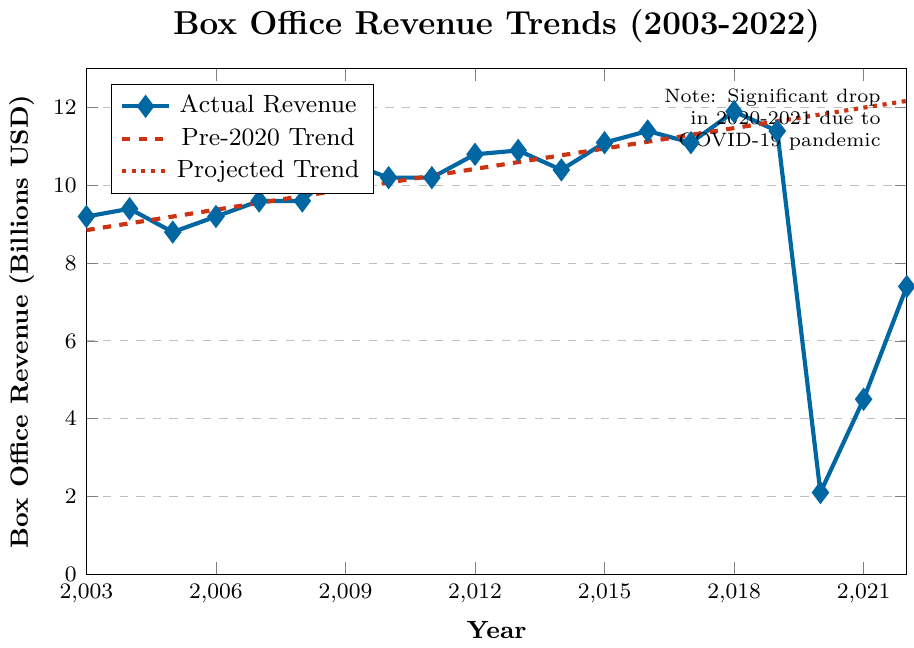How did the box office revenue change from 2019 to 2020? The box office revenue dropped dramatically from 11.4 billion USD in 2019 to 2.1 billion USD in 2020. This is a difference of 11.4 - 2.1 = 9.3 billion USD.
Answer: It decreased by 9.3 billion USD Which year had the highest box office revenue between 2003 and 2022? The highest box office revenue occurred in 2018, with a revenue of 11.9 billion USD, according to the graph.
Answer: 2018 What is the general trend of box office revenues from 2003 to 2019? The general trend is an increasing one. From 2003 to 2019, the box office revenue shows a gradual increase from 9.2 billion USD in 2003 to 11.4 billion USD in 2019.
Answer: Increasing trend What is the difference in box office revenue between the highest and lowest years on the graph? The highest box office revenue is 11.9 billion USD in 2018, and the lowest is 2.1 billion USD in 2020. The difference is 11.9 - 2.1 = 9.8 billion USD.
Answer: 9.8 billion USD How did the box office revenue change from 2021 to 2022, and by how much? The box office revenue increased from 4.5 billion USD in 2021 to 7.4 billion USD in 2022. The change is an increase of 7.4 - 4.5 = 2.9 billion USD.
Answer: Increased by 2.9 billion USD Which years show the revenue staying the same, and what was the revenue? The years 2007 and 2008 both show the same box office revenue of 9.6 billion USD.
Answer: 2007 and 2008, 9.6 billion USD What does the note in the top right corner of the graph indicate about the trend? The note indicates a significant drop in 2020-2021 due to the COVID-19 pandemic, explaining the sharp decrease in box office revenue during those years.
Answer: COVID-19 pandemic impact Compare the box office revenue trends before and after 2020. What observations can you make? The trend before 2020 shows a consistent increase in box office revenue. After 2020, there is a sharp decline in 2020, followed by a gradual recovery in 2021 and 2022, as shown by the actual revenue compared to the dashed pre-2020 trend line.
Answer: Consistent increase before 2020, sharp decline in 2020, gradual recovery in 2021 and 2022 How does the revenue in 2022 compare to the projected trend if the COVID-19 pandemic hadn't occurred? The projected trend (dotted red line) suggests that without the pandemic, the revenue would have continued to increase beyond 2019. The actual revenue in 2022 (7.4 billion USD) is lower than the projected revenue, indicating the pandemic's lingering impact.
Answer: Lower than projected trend 